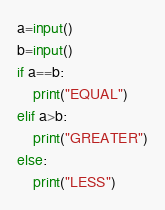<code> <loc_0><loc_0><loc_500><loc_500><_Python_>a=input()
b=input()
if a==b:
    print("EQUAL")
elif a>b:
    print("GREATER")
else:
    print("LESS")</code> 